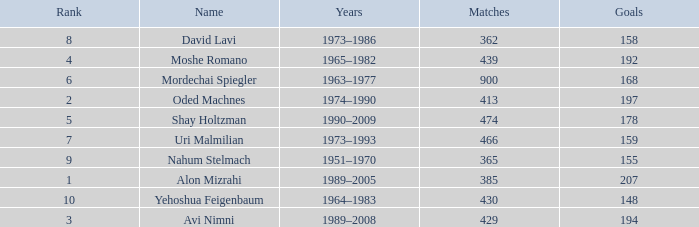What is the Rank of the player with 362 Matches? 8.0. 